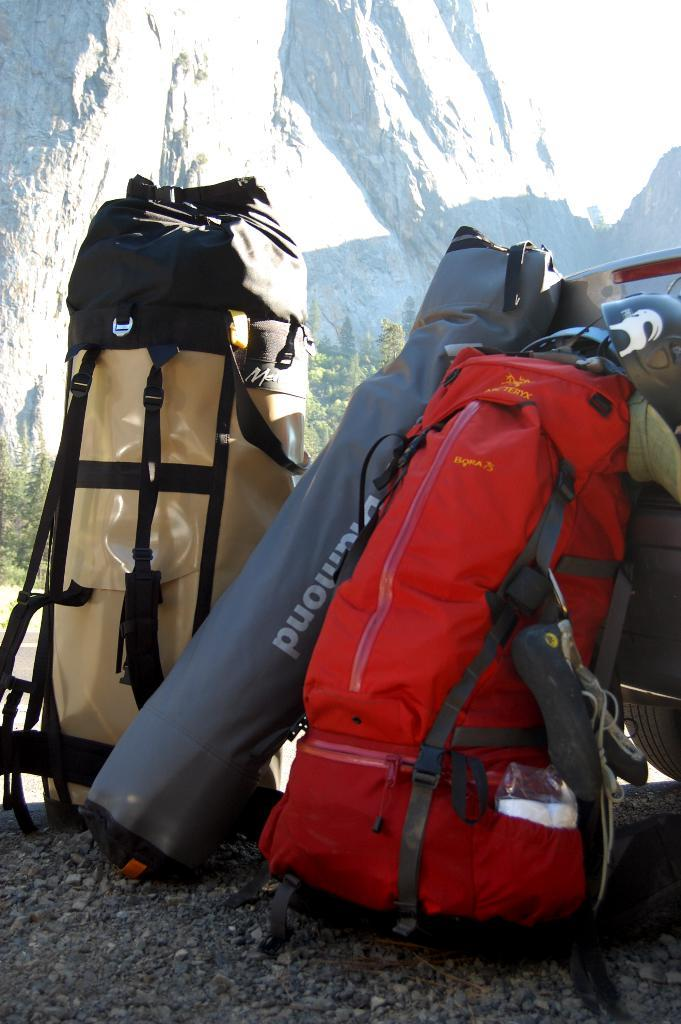How many bags are visible in the image? There are three bags in the image. Where are the bags located? The bags are on the ground. What type of notebook is visible in the image? There is no notebook present in the image. 